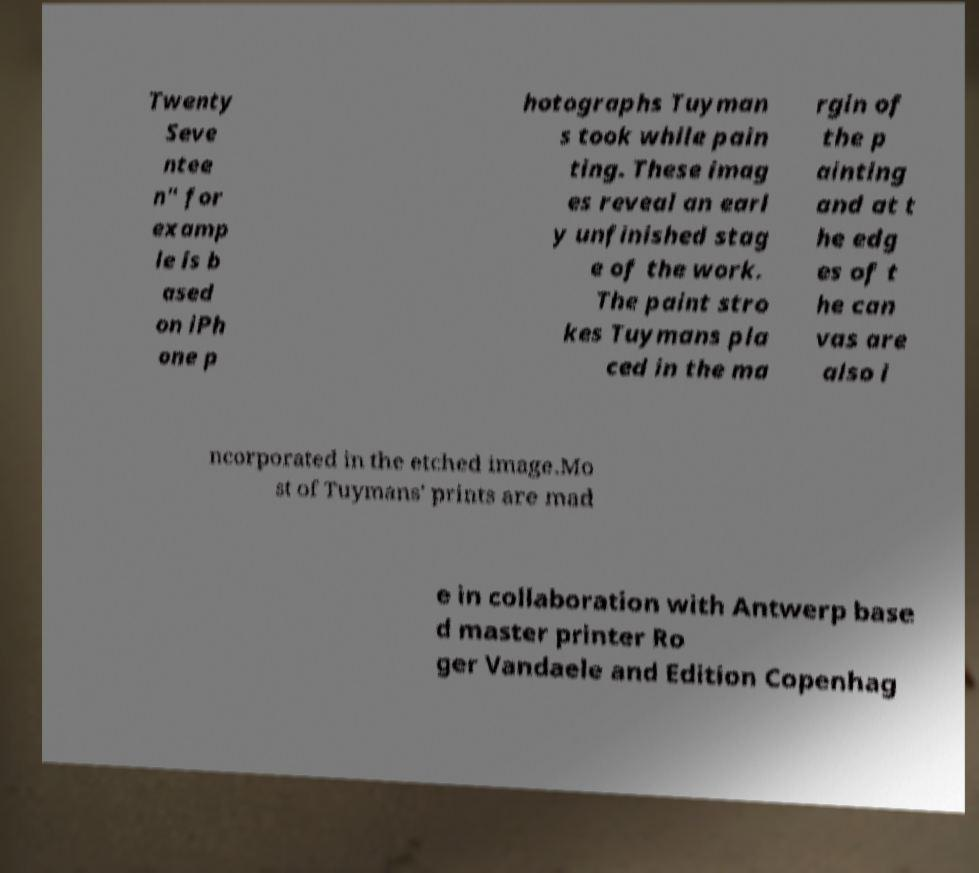For documentation purposes, I need the text within this image transcribed. Could you provide that? Twenty Seve ntee n" for examp le is b ased on iPh one p hotographs Tuyman s took while pain ting. These imag es reveal an earl y unfinished stag e of the work. The paint stro kes Tuymans pla ced in the ma rgin of the p ainting and at t he edg es of t he can vas are also i ncorporated in the etched image.Mo st of Tuymans' prints are mad e in collaboration with Antwerp base d master printer Ro ger Vandaele and Edition Copenhag 